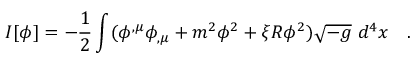Convert formula to latex. <formula><loc_0><loc_0><loc_500><loc_500>I [ \phi ] = - \frac { 1 } { 2 } \int ( \phi ^ { , \mu } \phi _ { , \mu } + m ^ { 2 } \phi ^ { 2 } + \xi R \phi ^ { 2 } ) \sqrt { - g } d ^ { 4 } x .</formula> 